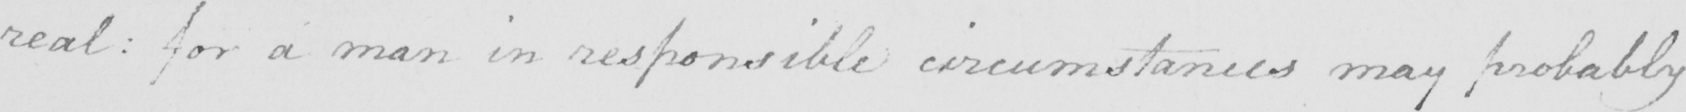Please transcribe the handwritten text in this image. real :  for a man in responsible circumstances may probably 